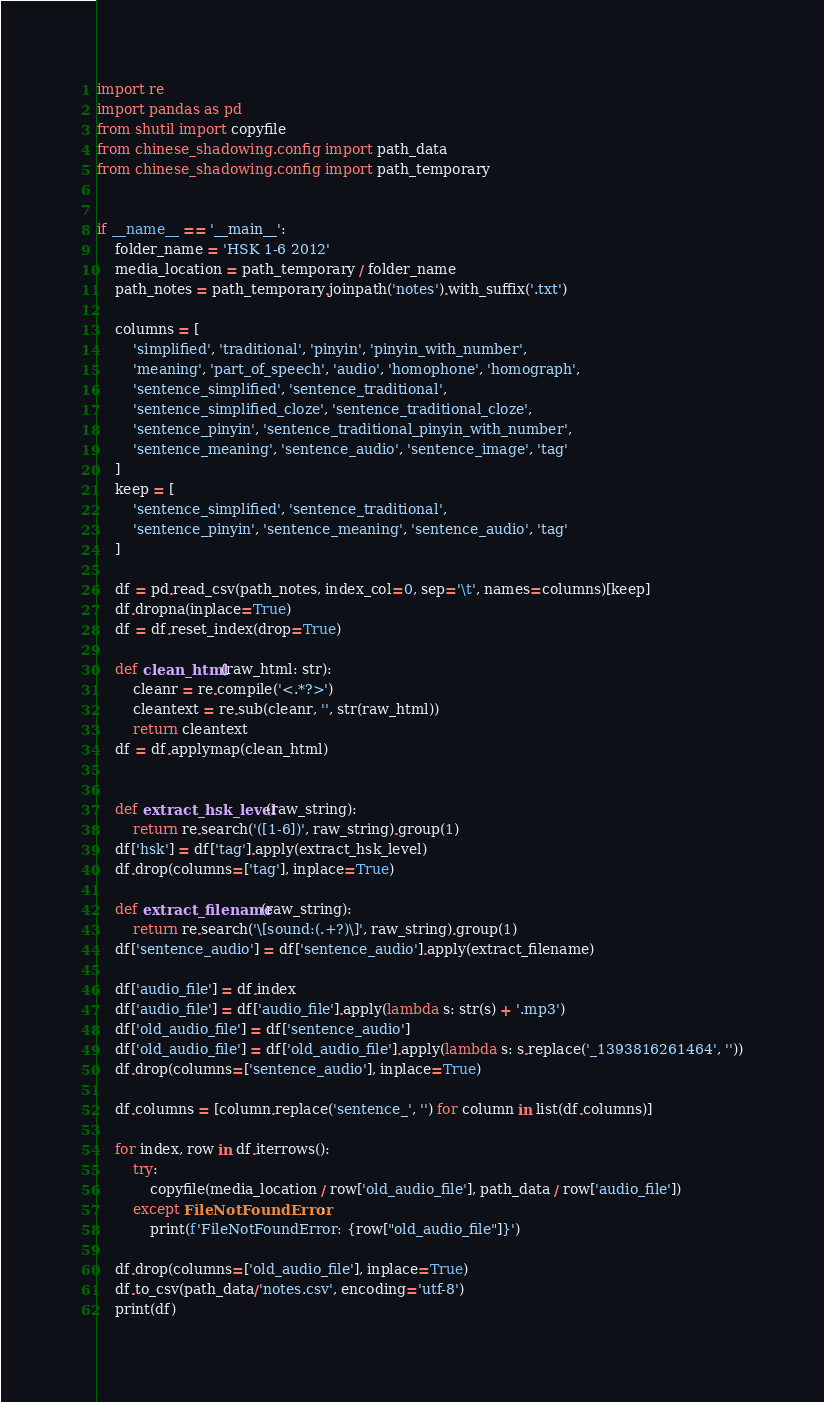Convert code to text. <code><loc_0><loc_0><loc_500><loc_500><_Python_>import re
import pandas as pd
from shutil import copyfile
from chinese_shadowing.config import path_data
from chinese_shadowing.config import path_temporary


if __name__ == '__main__':
    folder_name = 'HSK 1-6 2012'
    media_location = path_temporary / folder_name
    path_notes = path_temporary.joinpath('notes').with_suffix('.txt')

    columns = [
        'simplified', 'traditional', 'pinyin', 'pinyin_with_number',
        'meaning', 'part_of_speech', 'audio', 'homophone', 'homograph',
        'sentence_simplified', 'sentence_traditional',
        'sentence_simplified_cloze', 'sentence_traditional_cloze',
        'sentence_pinyin', 'sentence_traditional_pinyin_with_number',
        'sentence_meaning', 'sentence_audio', 'sentence_image', 'tag'
    ]
    keep = [
        'sentence_simplified', 'sentence_traditional',
        'sentence_pinyin', 'sentence_meaning', 'sentence_audio', 'tag'
    ]

    df = pd.read_csv(path_notes, index_col=0, sep='\t', names=columns)[keep]
    df.dropna(inplace=True)
    df = df.reset_index(drop=True)

    def clean_html(raw_html: str):
        cleanr = re.compile('<.*?>')
        cleantext = re.sub(cleanr, '', str(raw_html))
        return cleantext
    df = df.applymap(clean_html)


    def extract_hsk_level(raw_string):
        return re.search('([1-6])', raw_string).group(1)
    df['hsk'] = df['tag'].apply(extract_hsk_level)
    df.drop(columns=['tag'], inplace=True)

    def extract_filename(raw_string):
        return re.search('\[sound:(.+?)\]', raw_string).group(1)
    df['sentence_audio'] = df['sentence_audio'].apply(extract_filename)

    df['audio_file'] = df.index
    df['audio_file'] = df['audio_file'].apply(lambda s: str(s) + '.mp3')
    df['old_audio_file'] = df['sentence_audio']
    df['old_audio_file'] = df['old_audio_file'].apply(lambda s: s.replace('_1393816261464', ''))
    df.drop(columns=['sentence_audio'], inplace=True)

    df.columns = [column.replace('sentence_', '') for column in list(df.columns)]

    for index, row in df.iterrows():
        try:
            copyfile(media_location / row['old_audio_file'], path_data / row['audio_file'])
        except FileNotFoundError:
            print(f'FileNotFoundError: {row["old_audio_file"]}')

    df.drop(columns=['old_audio_file'], inplace=True)
    df.to_csv(path_data/'notes.csv', encoding='utf-8')
    print(df)
</code> 